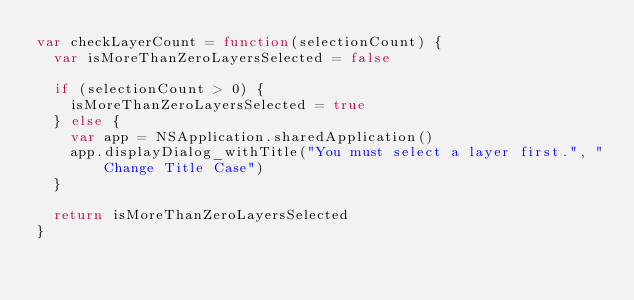<code> <loc_0><loc_0><loc_500><loc_500><_JavaScript_>var checkLayerCount = function(selectionCount) {
  var isMoreThanZeroLayersSelected = false

  if (selectionCount > 0) {
    isMoreThanZeroLayersSelected = true
  } else {
    var app = NSApplication.sharedApplication()
    app.displayDialog_withTitle("You must select a layer first.", "Change Title Case")
  }

  return isMoreThanZeroLayersSelected
}
</code> 